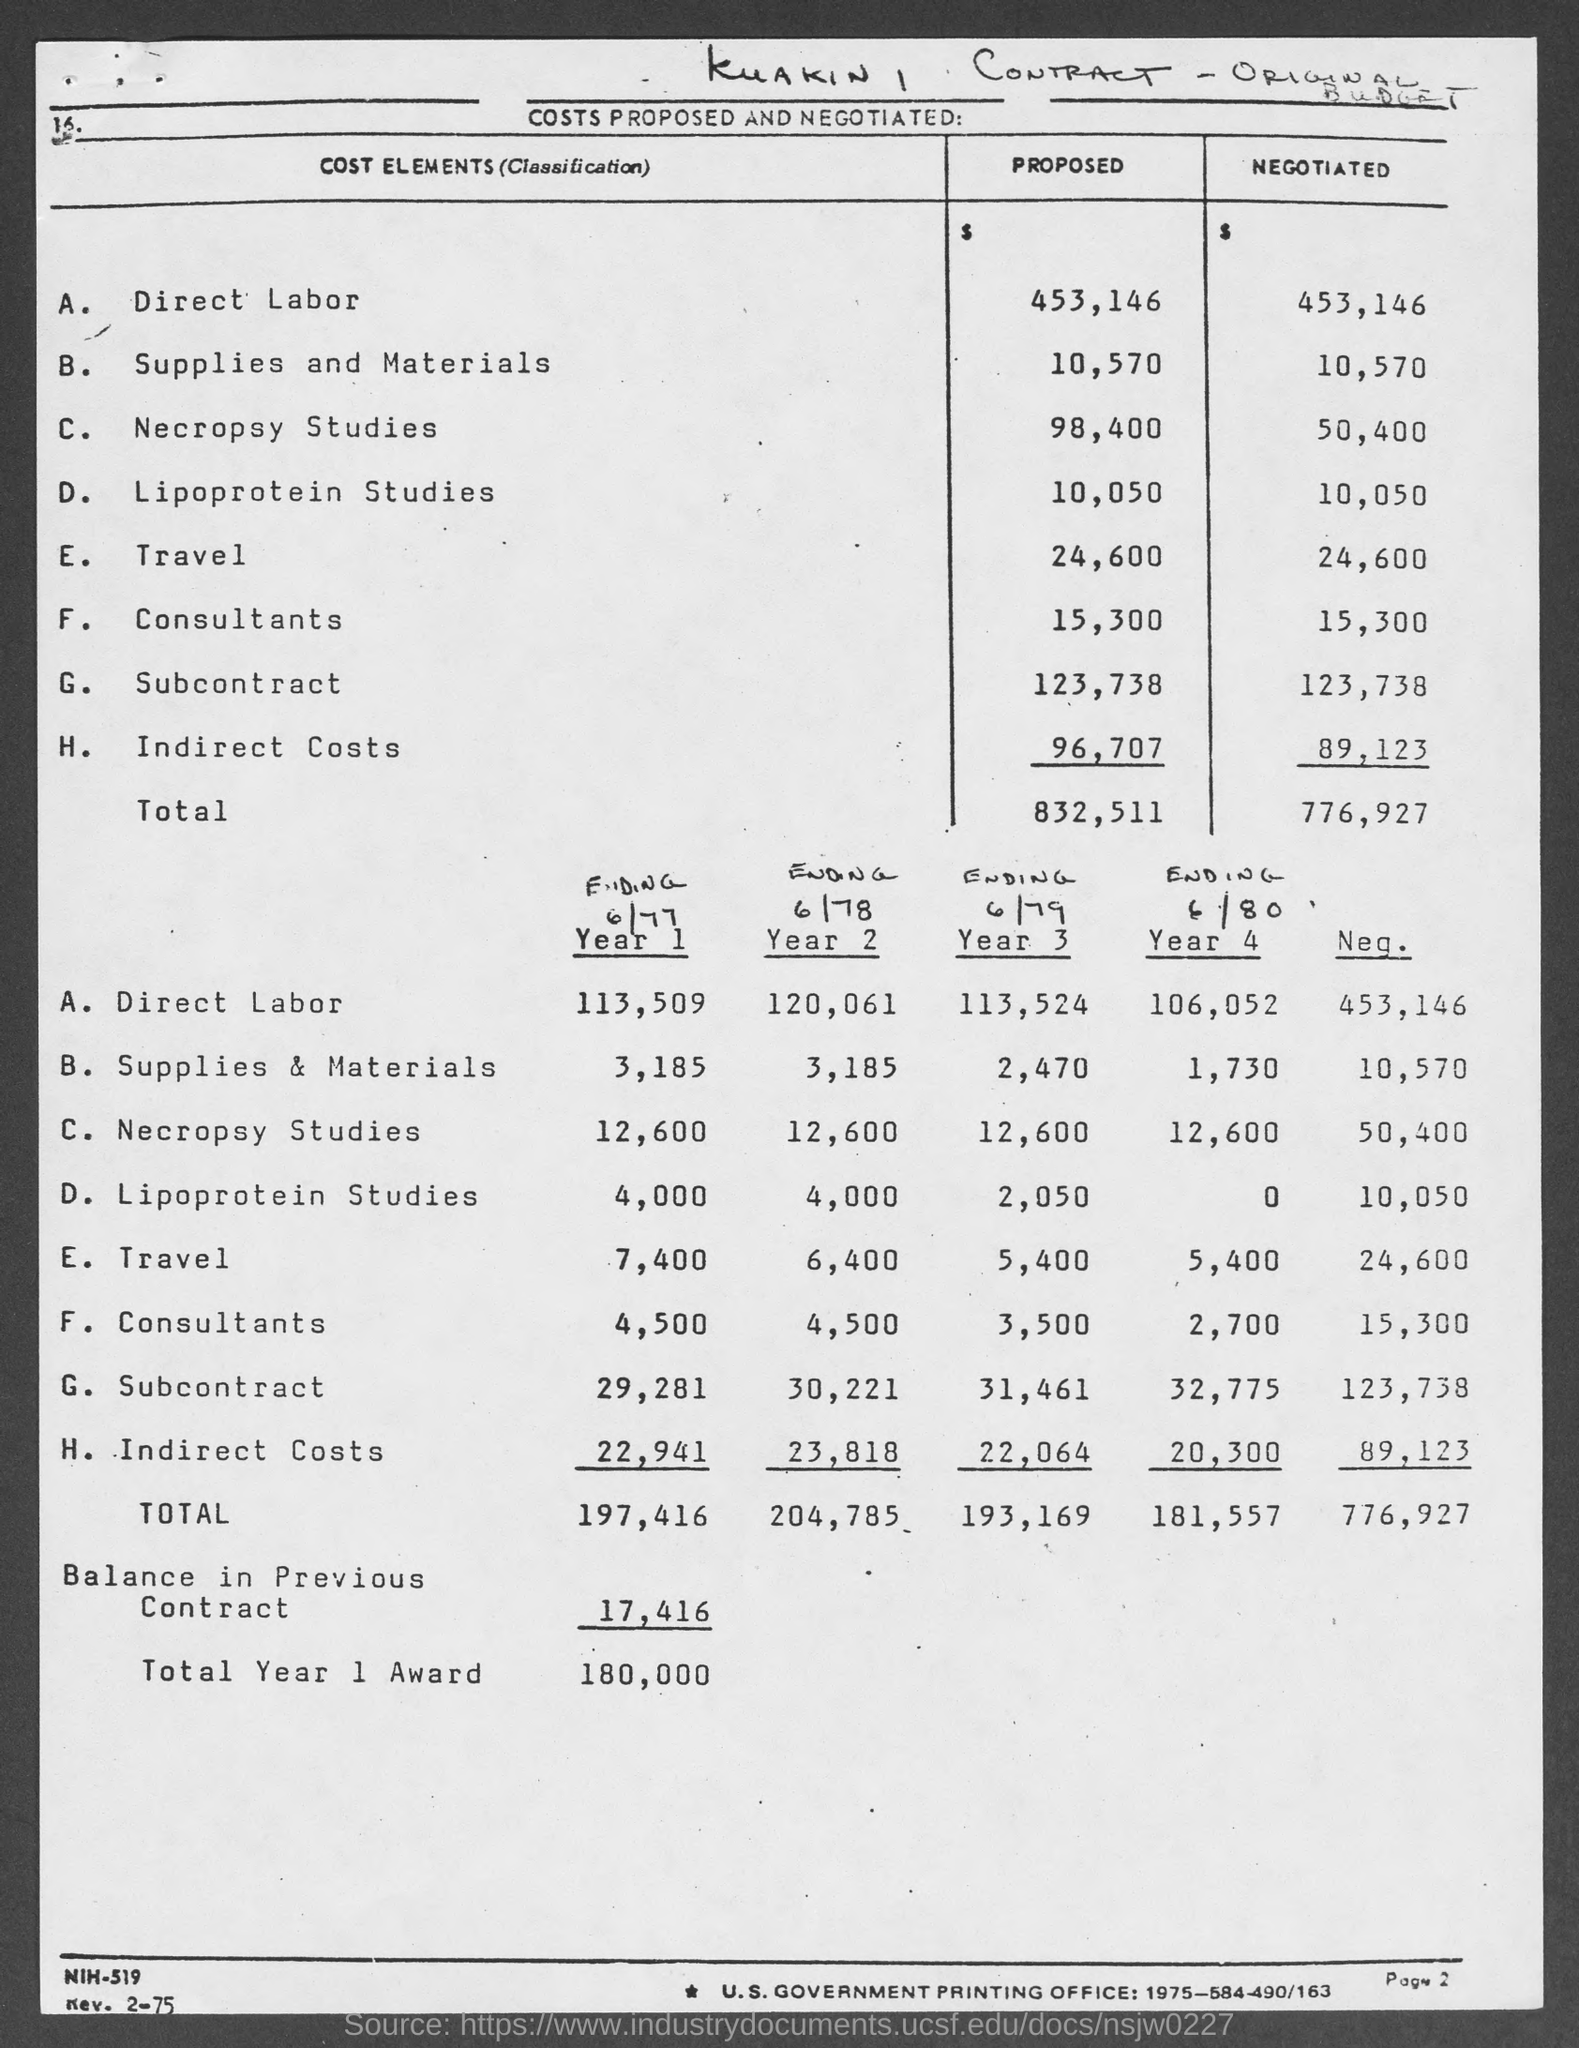What is the proposed cost for direct labor ?
Your answer should be very brief. 453,146. What is the proposed cost for supplies and materials ?
Your response must be concise. 10,570. What is the proposed cost for necropsy studies ?
Provide a short and direct response. 98,400. What is the proposed cost for lipoprotein studies ?
Ensure brevity in your answer.  10,050. What is the proposed cost for travel ?
Provide a short and direct response. 24,600. What is the proposed cost for consultants ?
Give a very brief answer. 15,300. What is the proposed cost for subcontract ?
Offer a very short reply. 123,738. What is the proposed costs for indirect costs?
Give a very brief answer. 96,707. What is the total proposed costs mentioned in the given table ?
Your answer should be compact. 832,511. What is the amount of balance in previous contract as mentioned in the given page ?
Offer a very short reply. 17,416. 